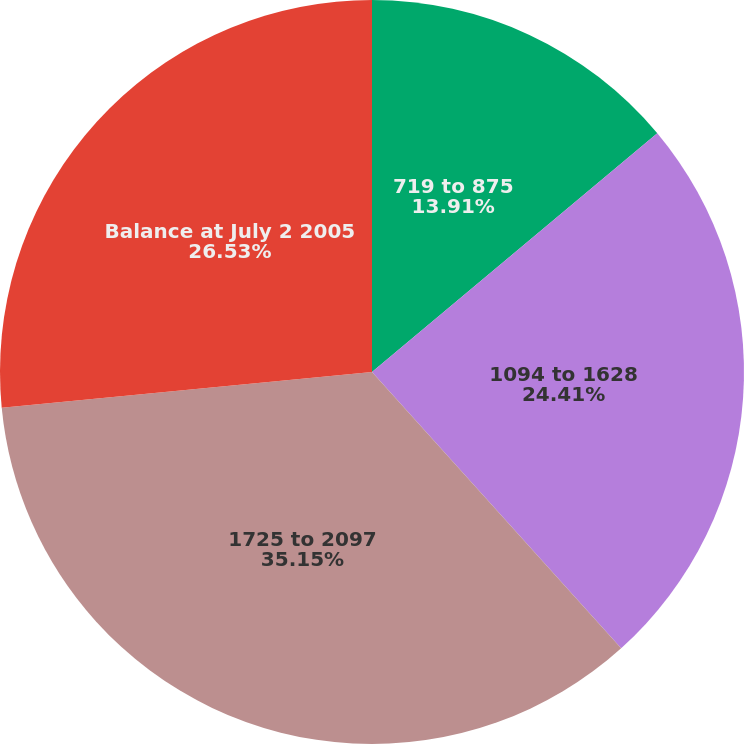Convert chart. <chart><loc_0><loc_0><loc_500><loc_500><pie_chart><fcel>719 to 875<fcel>1094 to 1628<fcel>1725 to 2097<fcel>Balance at July 2 2005<nl><fcel>13.91%<fcel>24.41%<fcel>35.15%<fcel>26.53%<nl></chart> 